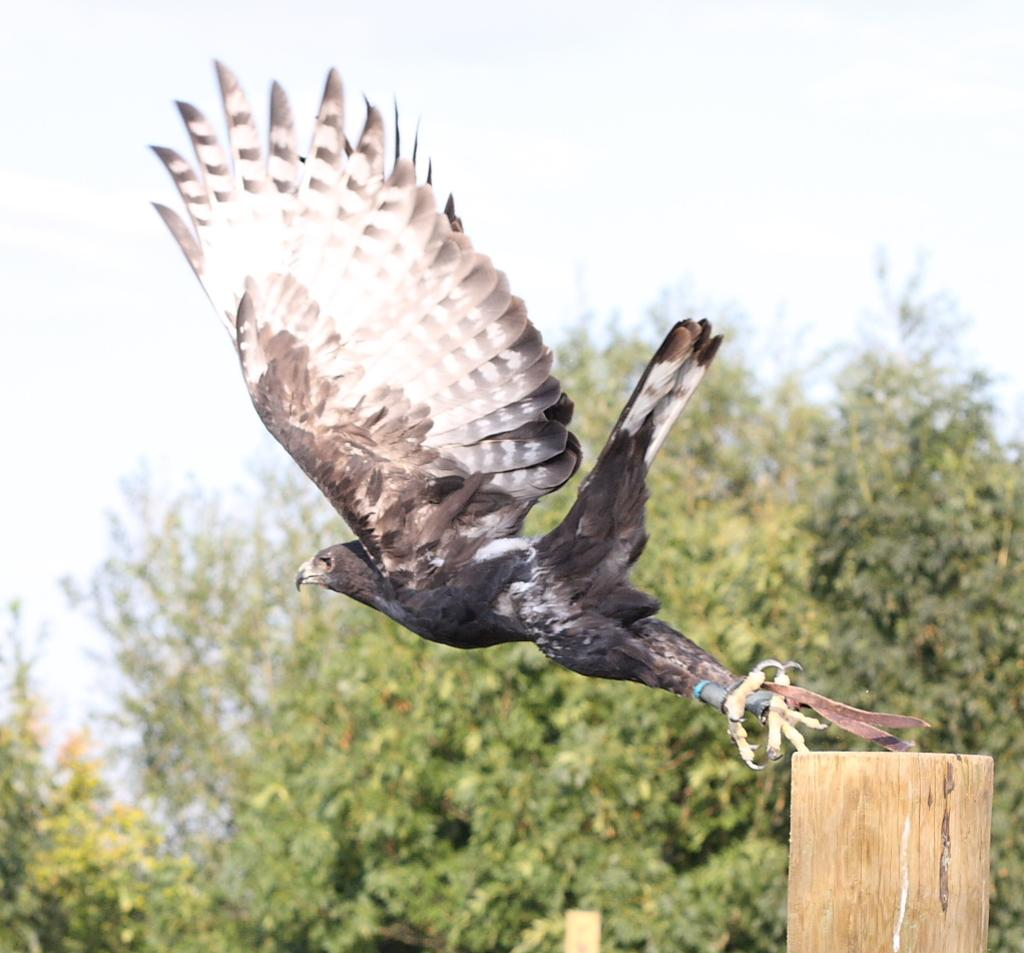What is the main subject of the image? The main subject of the image is a bird flying. What can be seen on the right side of the image? There is a wooden plank on the right side of the image. What type of natural environment is visible in the background of the image? There are trees in the background of the image. What is visible at the top of the image? The sky is visible at the top of the image. What type of education can be seen on the canvas in the image? There is no canvas or education present in the image; it features a bird flying and a wooden plank on the right side. 